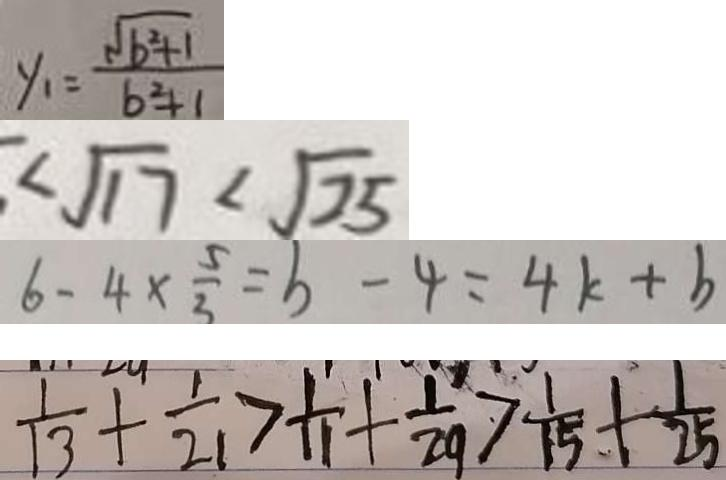Convert formula to latex. <formula><loc_0><loc_0><loc_500><loc_500>y _ { 1 } = \frac { \sqrt { b ^ { 2 } + 1 } } { b ^ { 2 } + 1 } 
 \sqrt { 1 7 } < \sqrt { 2 5 } 
 6 - 4 \times \frac { 5 } { 3 } = b - 4 = 4 k + b 
 \frac { 1 } { 1 3 } + \frac { 1 } { 2 1 } > \frac { 1 } { 1 1 } + \frac { 1 } { 2 9 } > \frac { 1 } { 1 5 } + \frac { 1 } { 2 5 }</formula> 